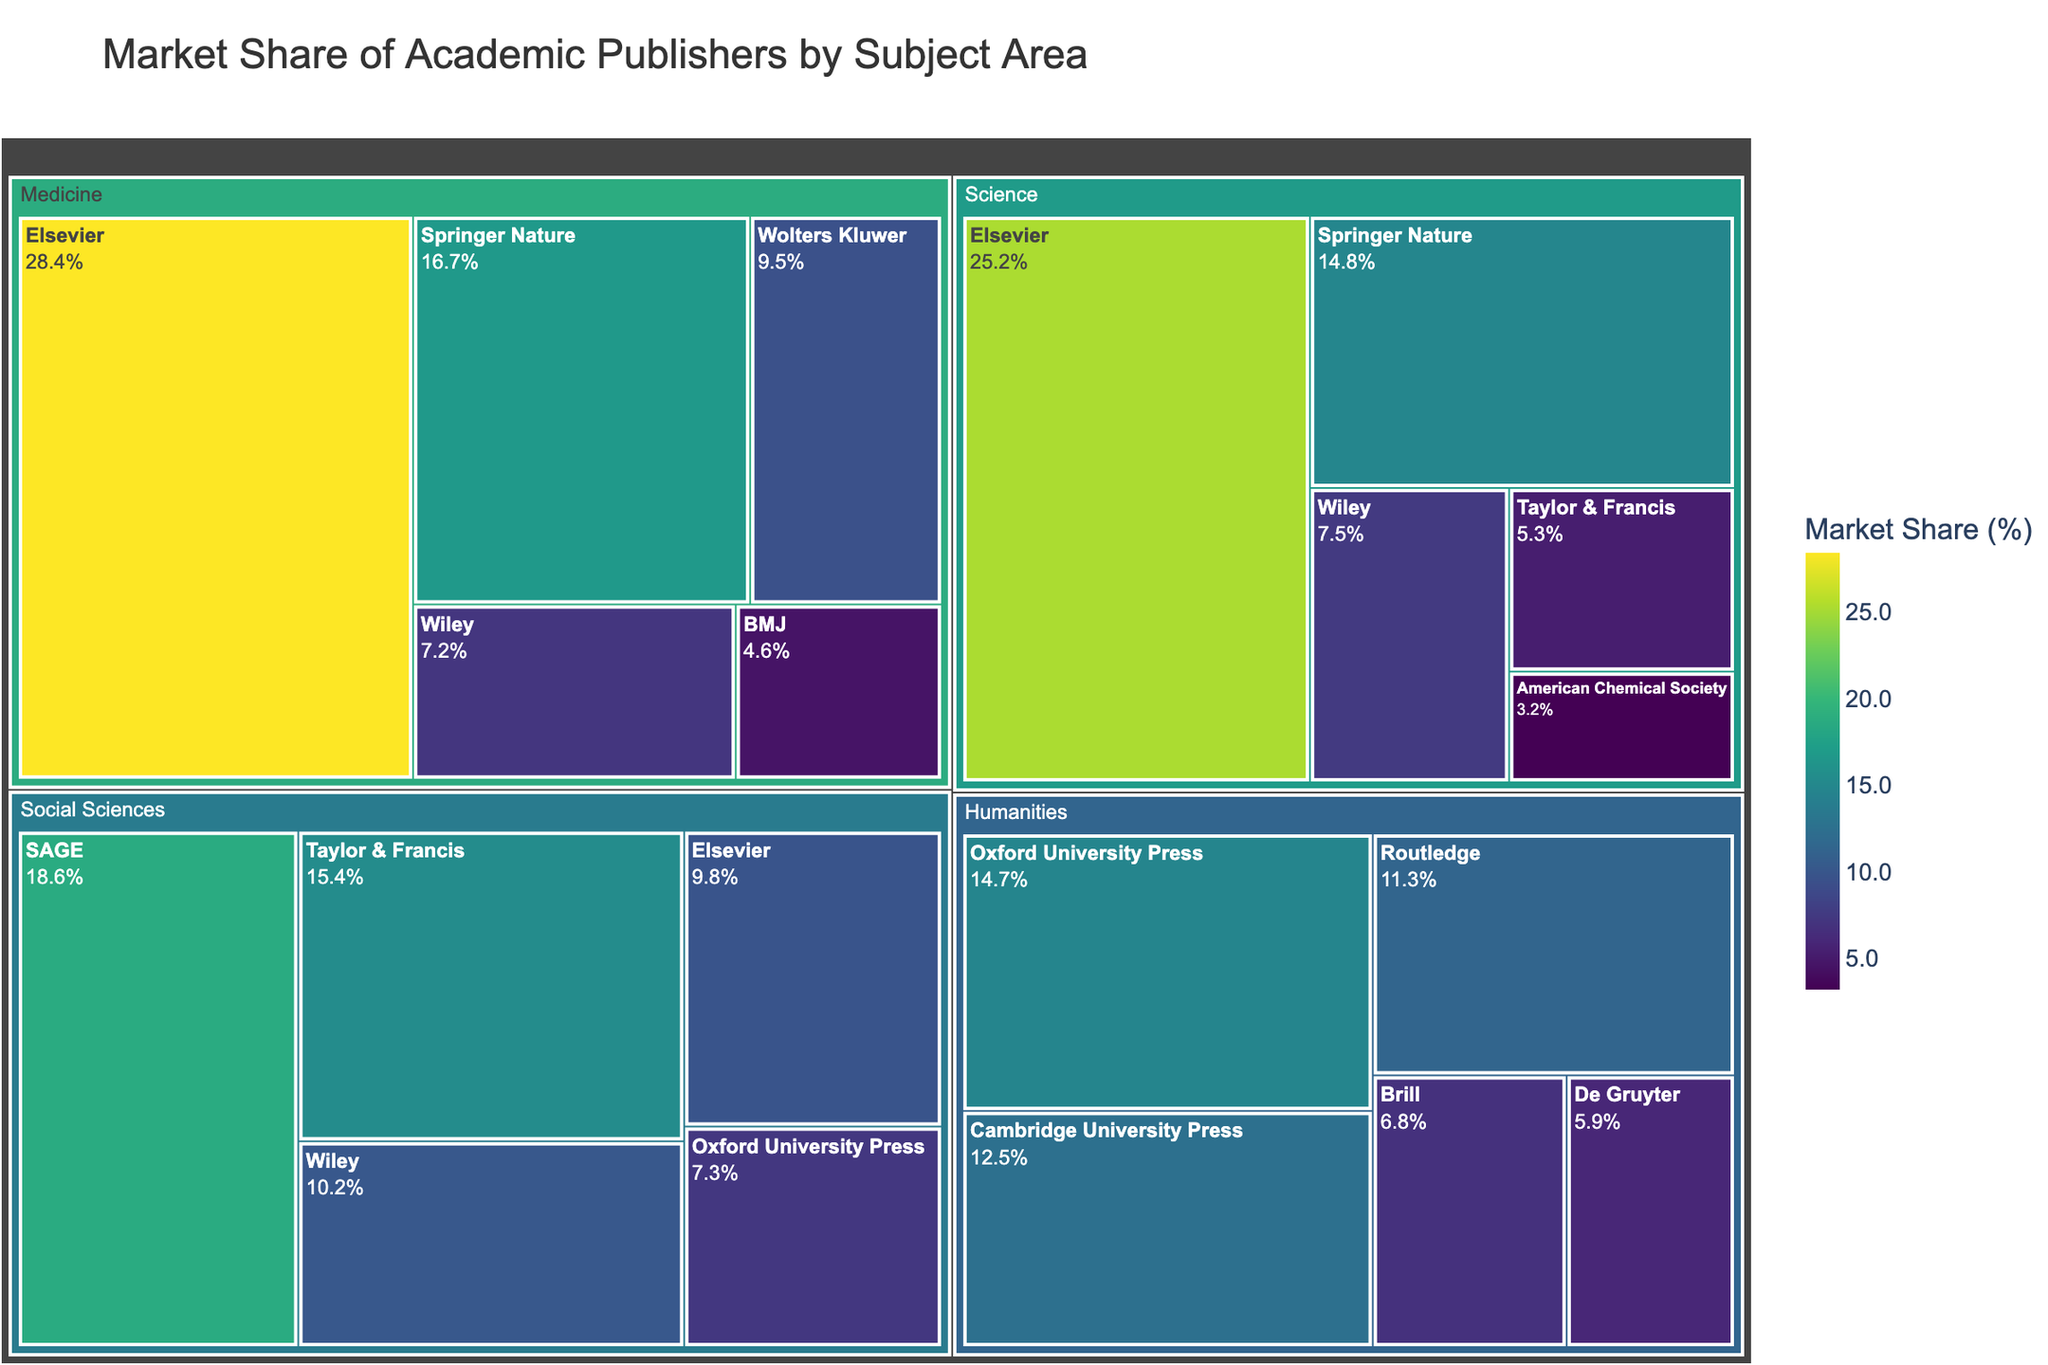What is the market share of Elsevier in the Science subject area? Locate the Science section in the treemap and find Elsevier. The market share value shown is 25.2%.
Answer: 25.2% Which publisher has the highest market share in Medicine? Locate the Medicine section in the treemap and identify the publisher with the largest tile, which is Elsevier at 28.4%.
Answer: Elsevier What is the combined market share of Springer Nature in Science and Medicine? Find Springer Nature in both the Science and Medicine sections and add their market shares: 14.8% (Science) + 16.7% (Medicine) = 31.5%.
Answer: 31.5% Which subject area has the highest market share for Taylor & Francis? Find Taylor & Francis in each subject area and compare their market shares: Science (5.3%), Social Sciences (15.4%), Humanities (not listed), Medicine (not listed). The highest is Social Sciences at 15.4%.
Answer: Social Sciences How does the market share of Oxford University Press compare between Social Sciences and Humanities? Find Oxford University Press in both the Social Sciences and Humanities sections: Social Sciences (7.3%), Humanities (14.7%). Compare these values, Oxford University Press has a higher market share in Humanities.
Answer: Higher in Humanities Which publishers appear in more than one subject area? Check for publishers listed in multiple subject areas. For example, Elsevier, Wiley, and Taylor & Francis appear in both Science and Social Sciences, as well as other subject areas.
Answer: Elsevier, Wiley, Taylor & Francis What is the total market share of the top three publishers in Medicine? Identify the top three publishers in Medicine: Elsevier (28.4%), Springer Nature (16.7%), and Wolters Kluwer (9.5%). Sum their market shares: 28.4% + 16.7% + 9.5% = 54.6%.
Answer: 54.6% Which subject area has the largest number of publishers listed? Count the number of publishers in each subject area in the treemap. Science and Humanities both have five publishers listed.
Answer: Science, Humanities What is the average market share of publishers in Humanities? Sum the market shares of the publishers in Humanities: 14.7% + 12.5% + 11.3% + 6.8% + 5.9% = 51.2%. Divide by the number of publishers: 51.2% / 5 = 10.24%.
Answer: 10.24% What is the difference in market share between the largest and smallest publishers in Social Sciences? Identify the market shares of the largest (SAGE, 18.6%) and smallest (Oxford University Press, 7.3%) publishers in Social Sciences. Calculate the difference: 18.6% - 7.3% = 11.3%.
Answer: 11.3% 